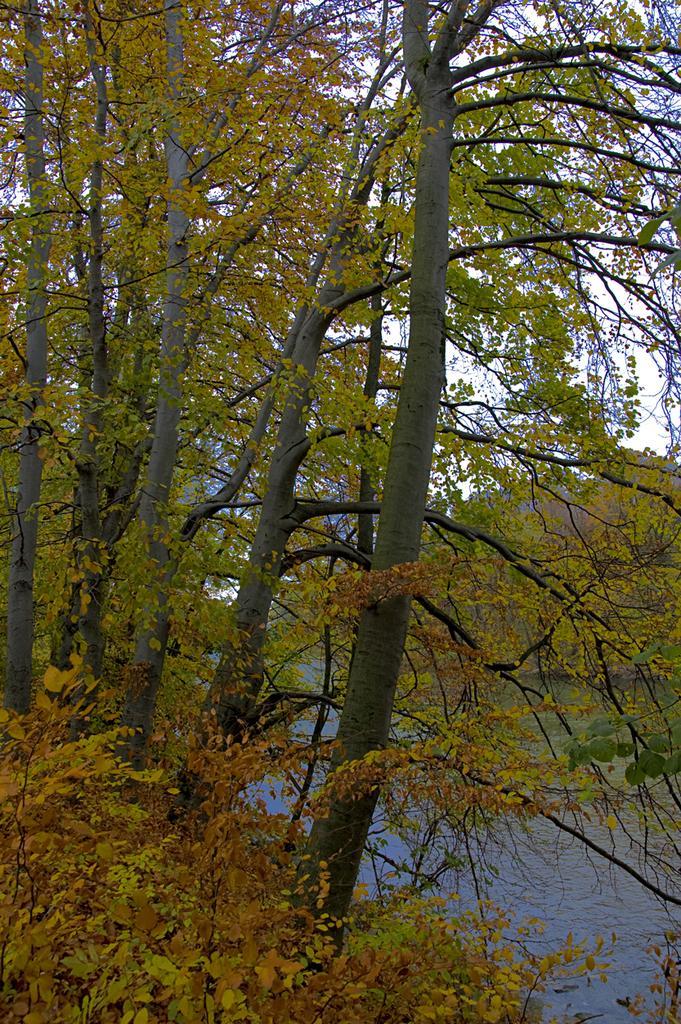Can you describe this image briefly? In the foreground of this image, there are trees. In the background, there is water and the sky. 